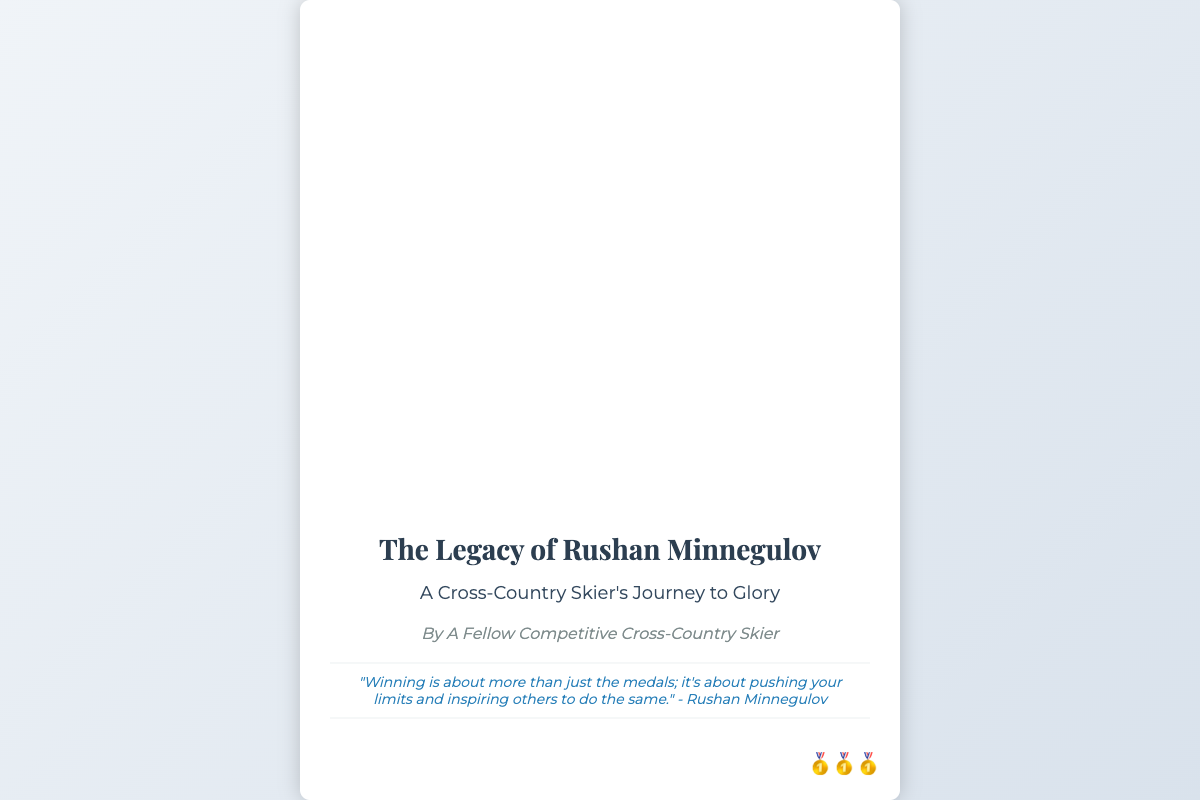What is the title of the book? The title is displayed prominently at the top of the cover.
Answer: The Legacy of Rushan Minnegulov Who is the author of the book? The author is mentioned directly below the title.
Answer: A Fellow Competitive Cross-Country Skier What is the subtitle of the book? The subtitle provides additional context about the book's focus.
Answer: A Cross-Country Skier's Journey to Glory What quote is featured on the cover? A quote is provided in a stylized section of the cover.
Answer: "Winning is about more than just the medals; it's about pushing your limits and inspiring others to do the same." - Rushan Minnegulov How many medals are depicted on the cover? Medals are represented by emojis in the bottom corner.
Answer: Three What kind of illustration is on the cover? The illustration depicts Rushan in action, showing his passion and achievement.
Answer: Skiing What colors are predominantly used in the background? The background features a gradient which contributes to the overall aesthetic.
Answer: Light blue and white 